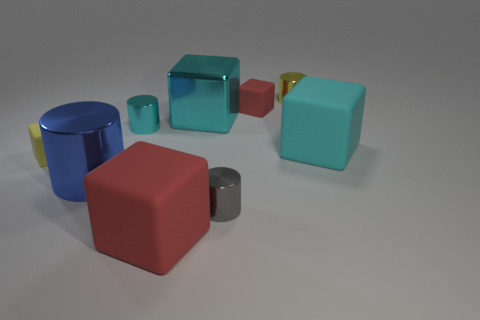Subtract all yellow cubes. How many cubes are left? 4 Subtract all big cyan rubber cubes. How many cubes are left? 4 Subtract all brown cubes. Subtract all red cylinders. How many cubes are left? 5 Add 1 tiny red rubber cubes. How many objects exist? 10 Subtract all blocks. How many objects are left? 4 Subtract all large brown metallic spheres. Subtract all small cyan shiny cylinders. How many objects are left? 8 Add 2 small red blocks. How many small red blocks are left? 3 Add 8 cyan metallic objects. How many cyan metallic objects exist? 10 Subtract 0 blue blocks. How many objects are left? 9 